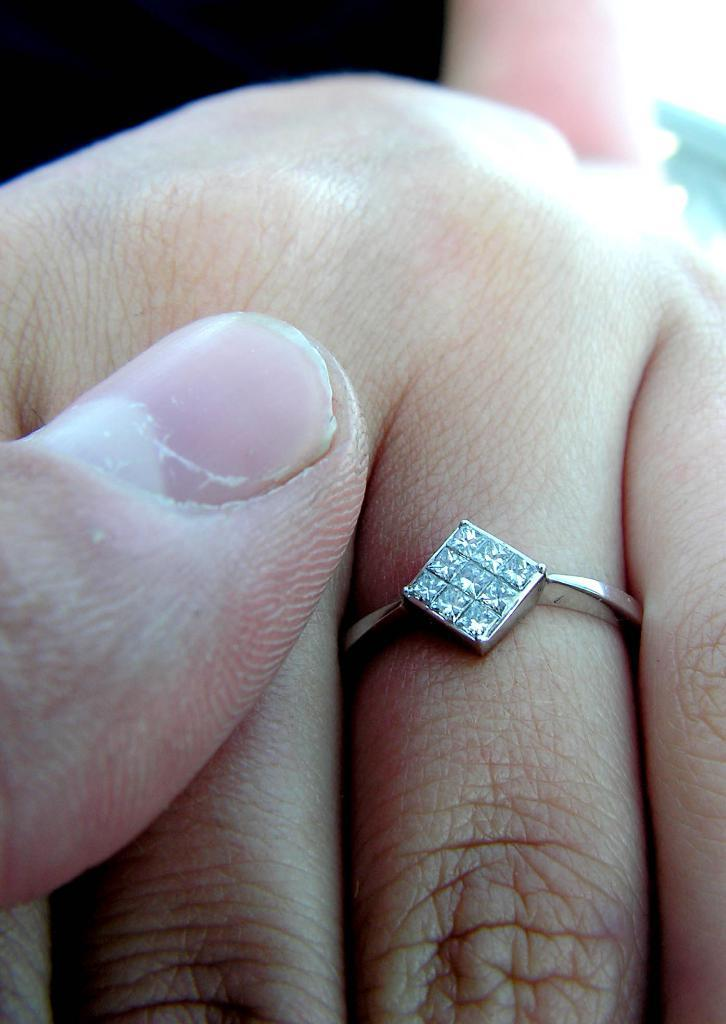What part of the body is visible in the image? There is a person's finger in the image. What is on the finger in the image? The finger has a ring on it. What type of stones are on the ring? The ring has diamond stones. What is the color of the ring? The ring is silver in color. What type of art can be seen on the person's finger in the image? There is no art visible on the person's finger in the image; it only shows a finger with a ring on it. 